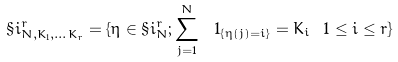Convert formula to latex. <formula><loc_0><loc_0><loc_500><loc_500>\S i _ { N , K _ { 1 } , \dots K _ { r } } ^ { r } = \{ \eta \in \S i _ { N } ^ { r } ; \sum _ { j = 1 } ^ { N } \ 1 _ { \{ \eta ( j ) = i \} } = K _ { i } \ 1 \leq i \leq r \}</formula> 